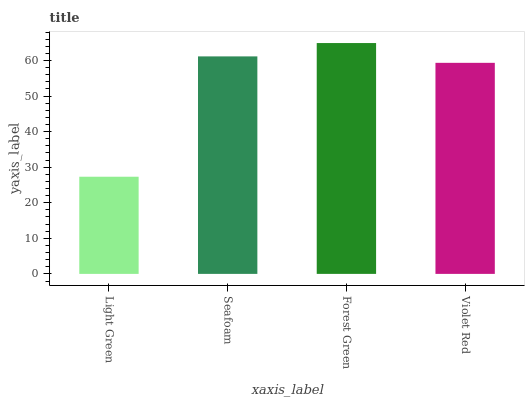Is Light Green the minimum?
Answer yes or no. Yes. Is Forest Green the maximum?
Answer yes or no. Yes. Is Seafoam the minimum?
Answer yes or no. No. Is Seafoam the maximum?
Answer yes or no. No. Is Seafoam greater than Light Green?
Answer yes or no. Yes. Is Light Green less than Seafoam?
Answer yes or no. Yes. Is Light Green greater than Seafoam?
Answer yes or no. No. Is Seafoam less than Light Green?
Answer yes or no. No. Is Seafoam the high median?
Answer yes or no. Yes. Is Violet Red the low median?
Answer yes or no. Yes. Is Violet Red the high median?
Answer yes or no. No. Is Seafoam the low median?
Answer yes or no. No. 